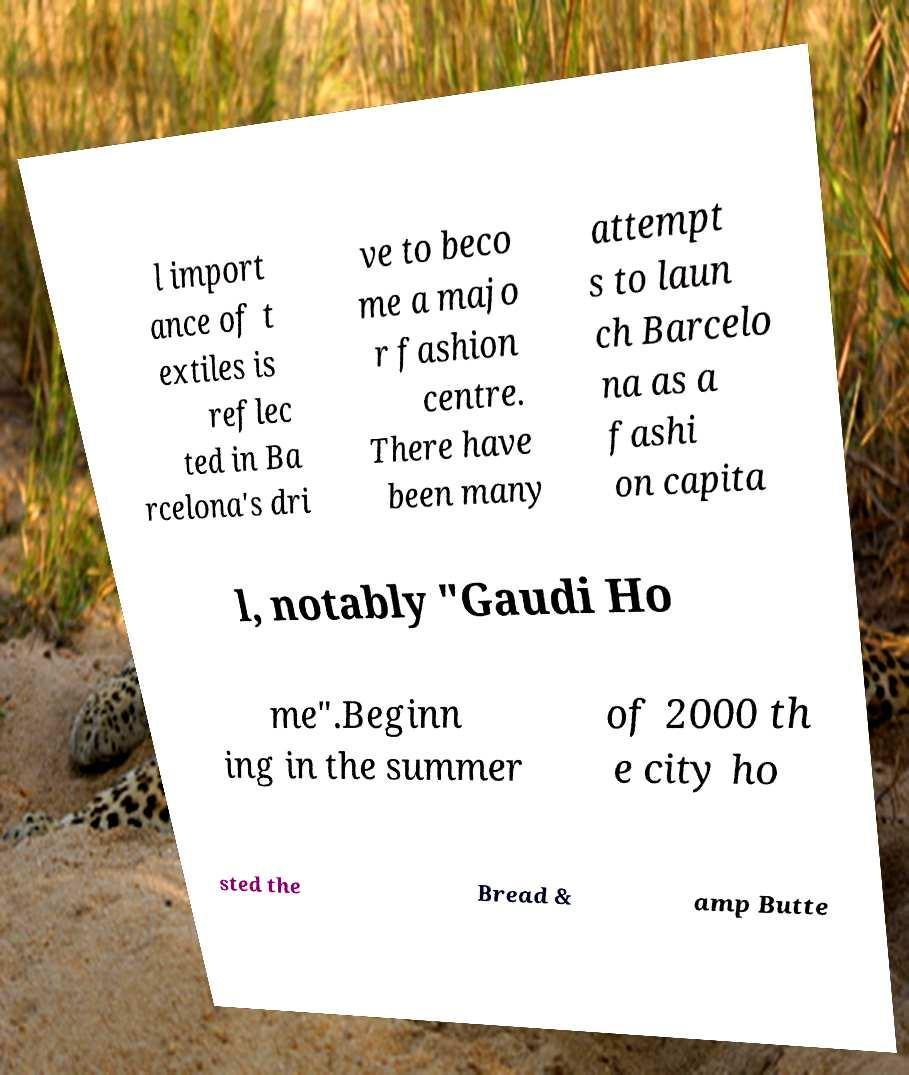Can you read and provide the text displayed in the image?This photo seems to have some interesting text. Can you extract and type it out for me? l import ance of t extiles is reflec ted in Ba rcelona's dri ve to beco me a majo r fashion centre. There have been many attempt s to laun ch Barcelo na as a fashi on capita l, notably "Gaudi Ho me".Beginn ing in the summer of 2000 th e city ho sted the Bread & amp Butte 